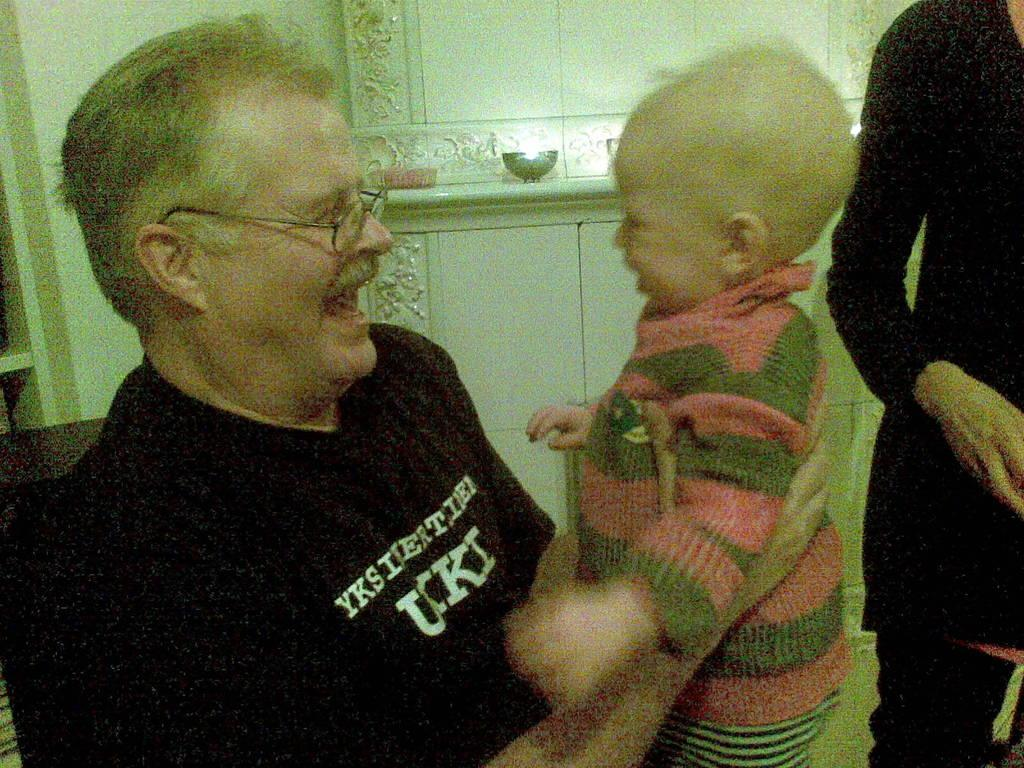How many people are in the image? There are a few people in the image. What can be seen in the background of the image? There is a wall and a pole in the background of the image. What is on the pole in the background of the image? There are objects on the pole in the background of the image. Can you tell me how many times the person in the image coughed? There is no information about anyone coughing in the image, so it cannot be determined. 